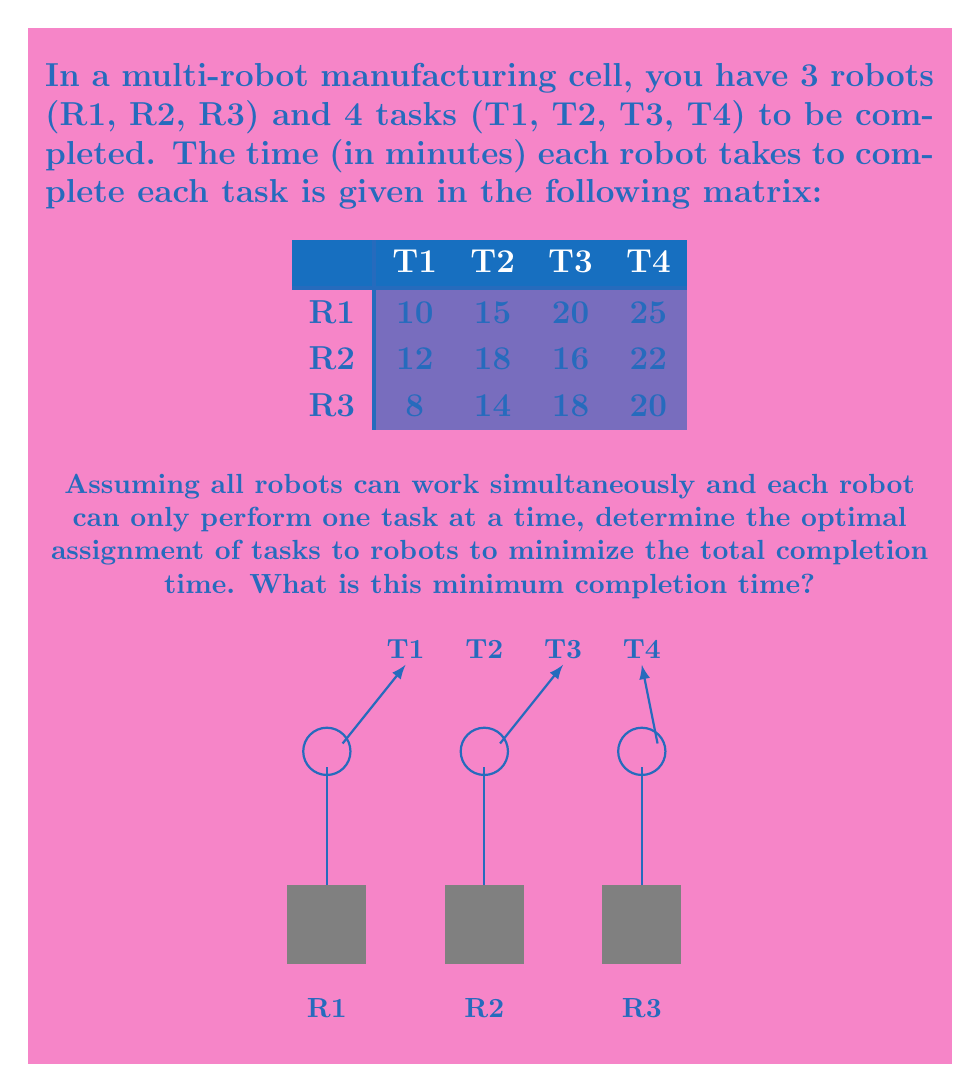Can you answer this question? To solve this problem, we can use the Hungarian algorithm for assignment problems. However, for this small-scale problem, we can also use a simpler approach:

1) First, observe that we need to assign all 4 tasks, and one robot will have to perform two tasks.

2) The total completion time will be determined by the robot that takes the longest to complete its assigned task(s).

3) Let's try to minimize the maximum time taken by any robot:

   - Assign the longest task (T4) to the robot that can do it fastest: R3 (20 min)
   - For the remaining tasks, assign them to the robots that can do them fastest:
     T1 to R3 (8 min), T2 to R3 (14 min), T3 to R2 (16 min)

4) Now we have:
   R1: No tasks
   R2: T3 (16 min)
   R3: T1 (8 min), T2 (14 min), T4 (20 min)

5) The total time for R3 is 8 + 14 + 20 = 42 min, which is greater than R2's time.

6) We can improve this by moving T2 from R3 to R1:
   R1: T2 (15 min)
   R2: T3 (16 min)
   R3: T1 (8 min), T4 (20 min)

7) Now the completion times are:
   R1: 15 min
   R2: 16 min
   R3: 8 + 20 = 28 min

8) This is the optimal assignment, as any other arrangement would result in a longer total completion time.

The minimum completion time is determined by the robot that takes the longest, which is R3 at 28 minutes.
Answer: 28 minutes 